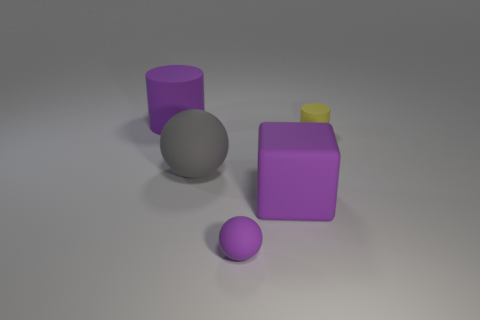Add 5 small yellow matte things. How many objects exist? 10 Subtract all cylinders. How many objects are left? 3 Add 3 large gray spheres. How many large gray spheres are left? 4 Add 3 spheres. How many spheres exist? 5 Subtract 0 green cubes. How many objects are left? 5 Subtract all gray metallic cubes. Subtract all large matte things. How many objects are left? 2 